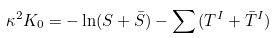<formula> <loc_0><loc_0><loc_500><loc_500>\kappa ^ { 2 } K _ { 0 } = - \ln ( S + \bar { S } ) - \sum { ( T ^ { I } + \bar { T } ^ { I } ) }</formula> 